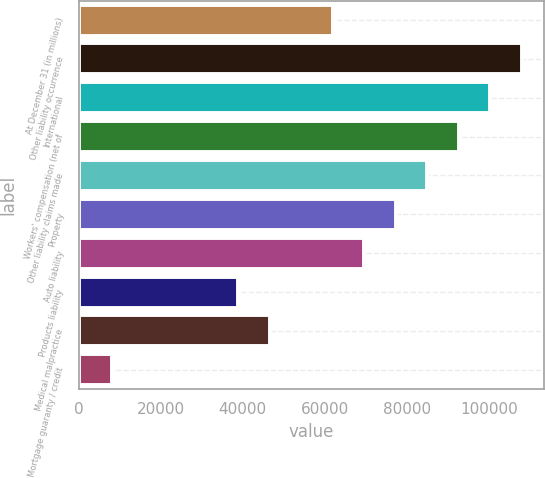Convert chart to OTSL. <chart><loc_0><loc_0><loc_500><loc_500><bar_chart><fcel>At December 31 (in millions)<fcel>Other liability occurrence<fcel>International<fcel>Workers' compensation (net of<fcel>Other liability claims made<fcel>Property<fcel>Auto liability<fcel>Products liability<fcel>Medical malpractice<fcel>Mortgage guaranty / credit<nl><fcel>61908.8<fcel>107962<fcel>100287<fcel>92611.2<fcel>84935.6<fcel>77260<fcel>69584.4<fcel>38882<fcel>46557.6<fcel>8179.6<nl></chart> 